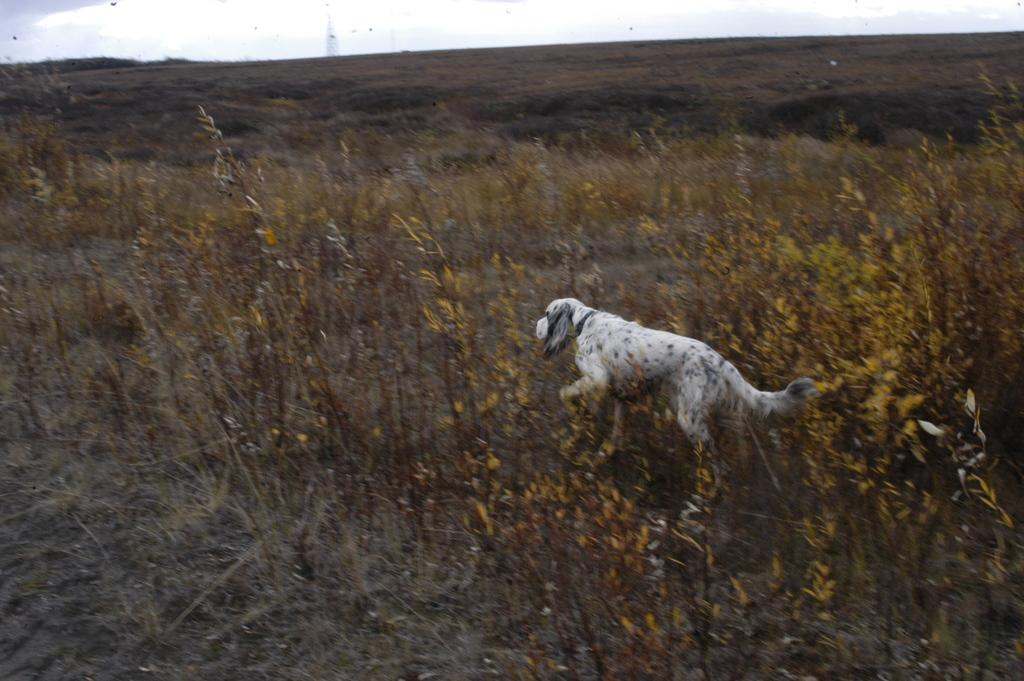What animal can be seen in the picture? There is a dog in the picture. What is the dog doing in the picture? The dog is running in the plants. What type of vegetation is present in the surrounding area? The surrounding area is full of grass. How many minutes does it take for the popcorn to pop in the image? There is no popcorn present in the image, so it is not possible to determine how long it would take to pop. 